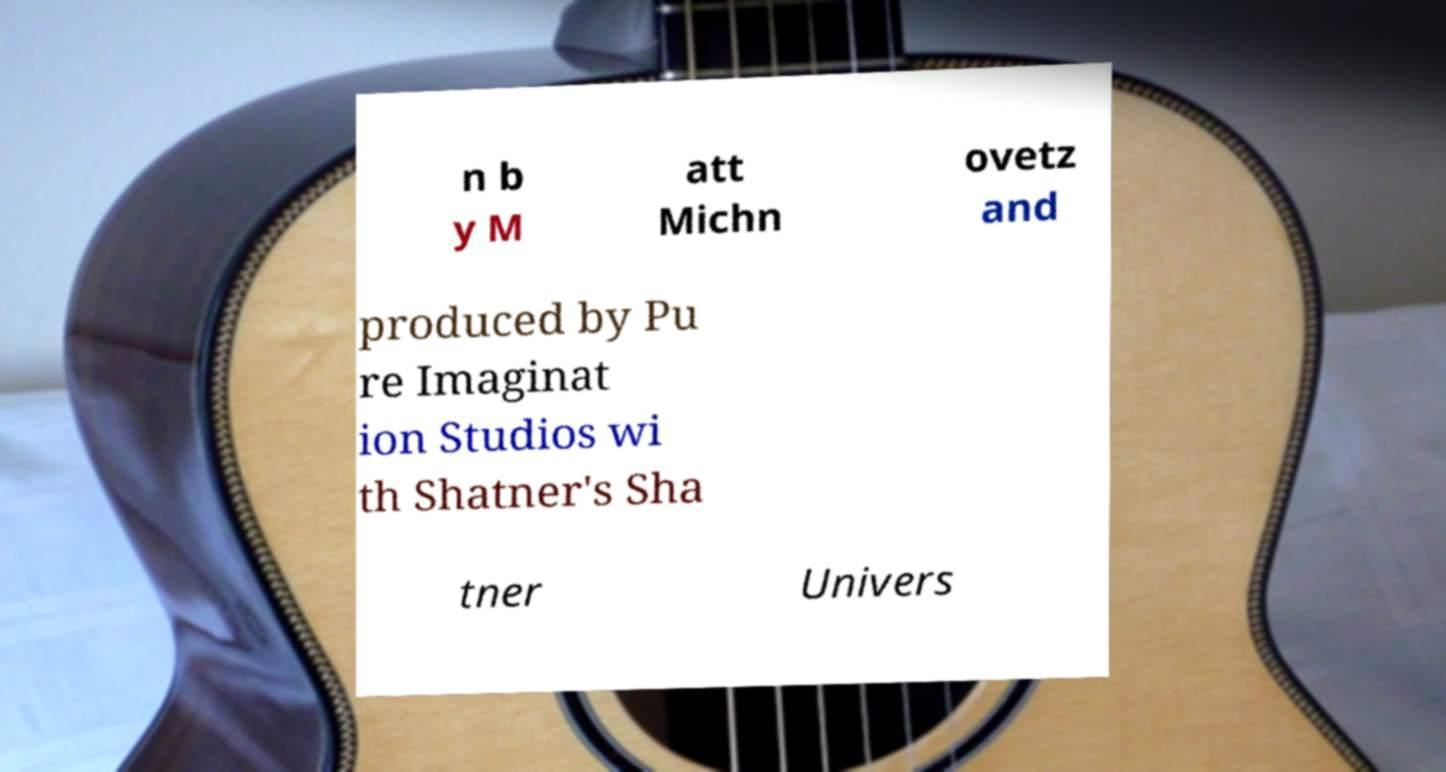For documentation purposes, I need the text within this image transcribed. Could you provide that? n b y M att Michn ovetz and produced by Pu re Imaginat ion Studios wi th Shatner's Sha tner Univers 